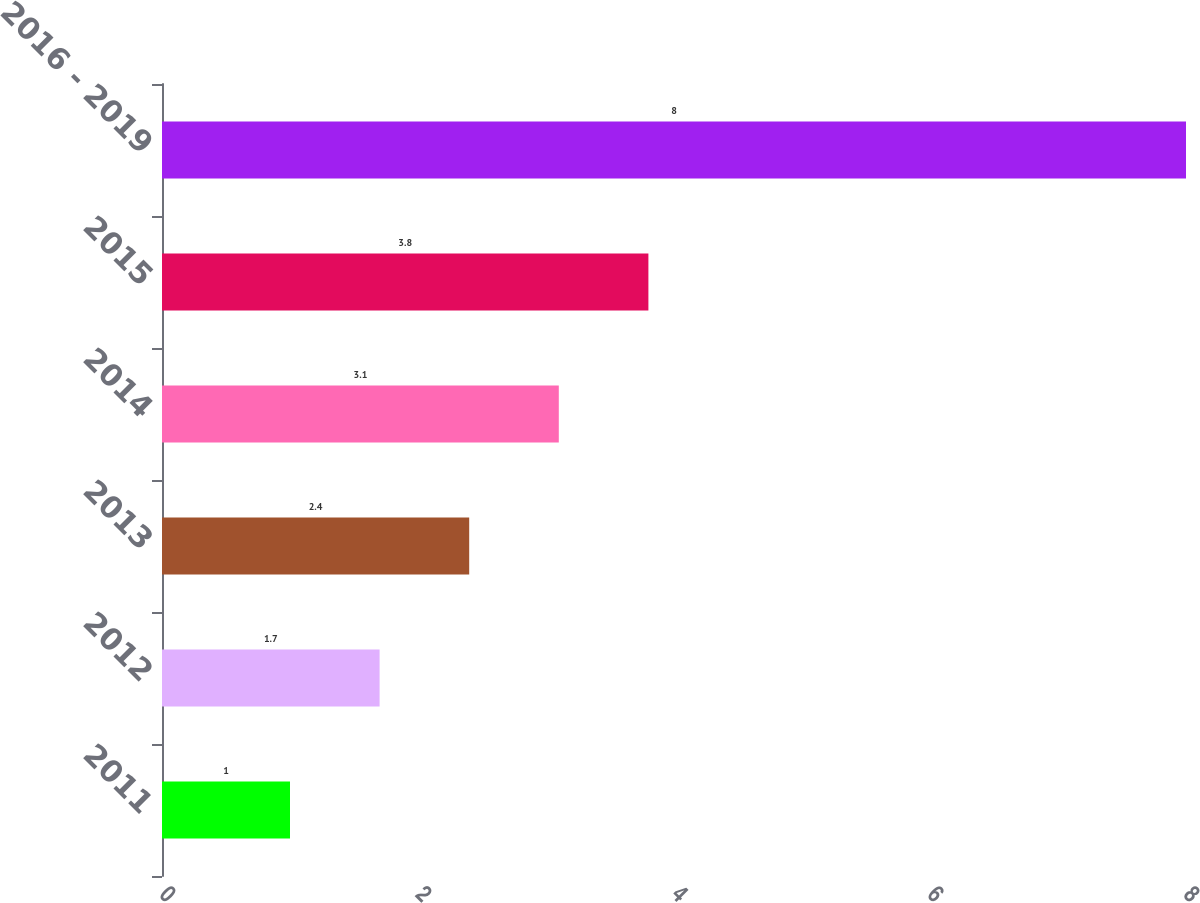<chart> <loc_0><loc_0><loc_500><loc_500><bar_chart><fcel>2011<fcel>2012<fcel>2013<fcel>2014<fcel>2015<fcel>2016 - 2019<nl><fcel>1<fcel>1.7<fcel>2.4<fcel>3.1<fcel>3.8<fcel>8<nl></chart> 